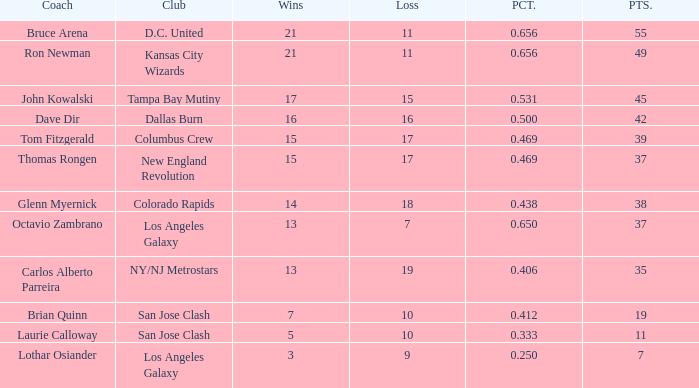What is the greatest percentage of bruce arena when he has over 11 game losses? None. 